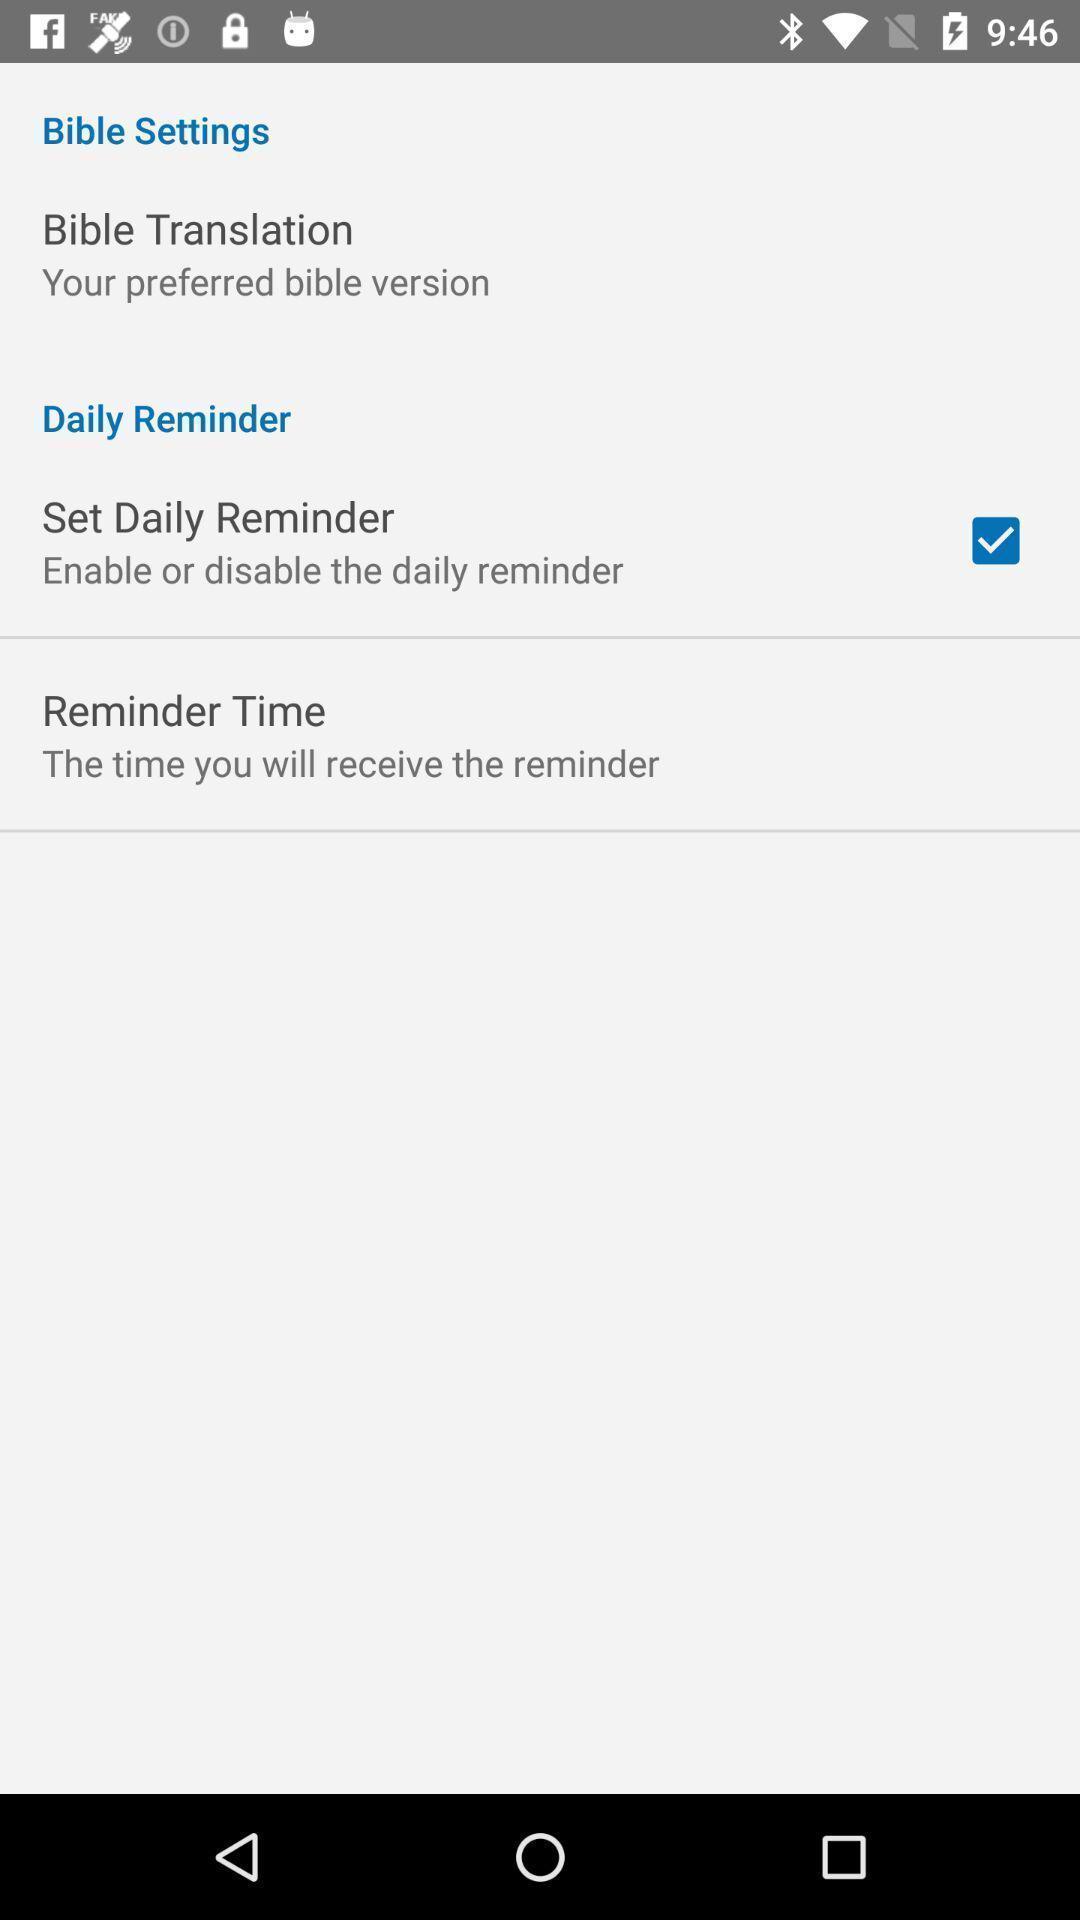Explain what's happening in this screen capture. Screen displaying multiple setting options. 